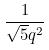<formula> <loc_0><loc_0><loc_500><loc_500>\frac { 1 } { \sqrt { 5 } q ^ { 2 } }</formula> 